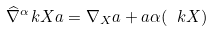Convert formula to latex. <formula><loc_0><loc_0><loc_500><loc_500>\widehat { \nabla } ^ { \alpha } _ { \ } k X a = \nabla _ { X } a + a \alpha ( \ k X )</formula> 